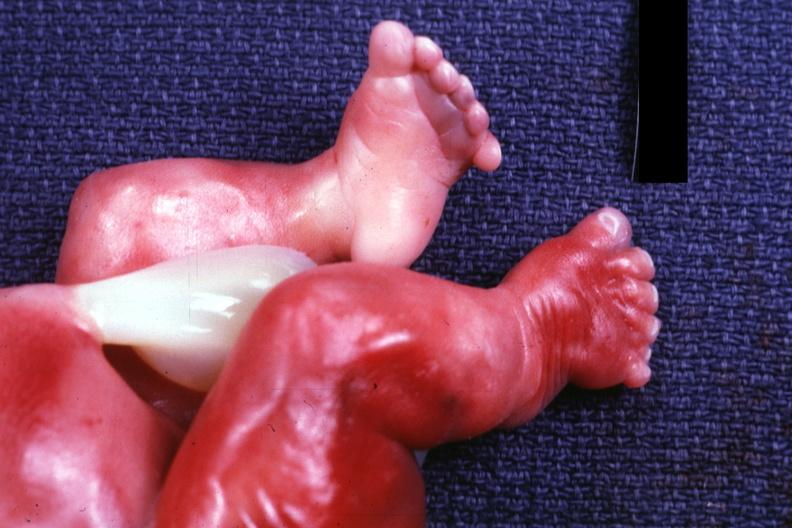does this section show newborn with renal polycystic disease legs are too short?
Answer the question using a single word or phrase. No 